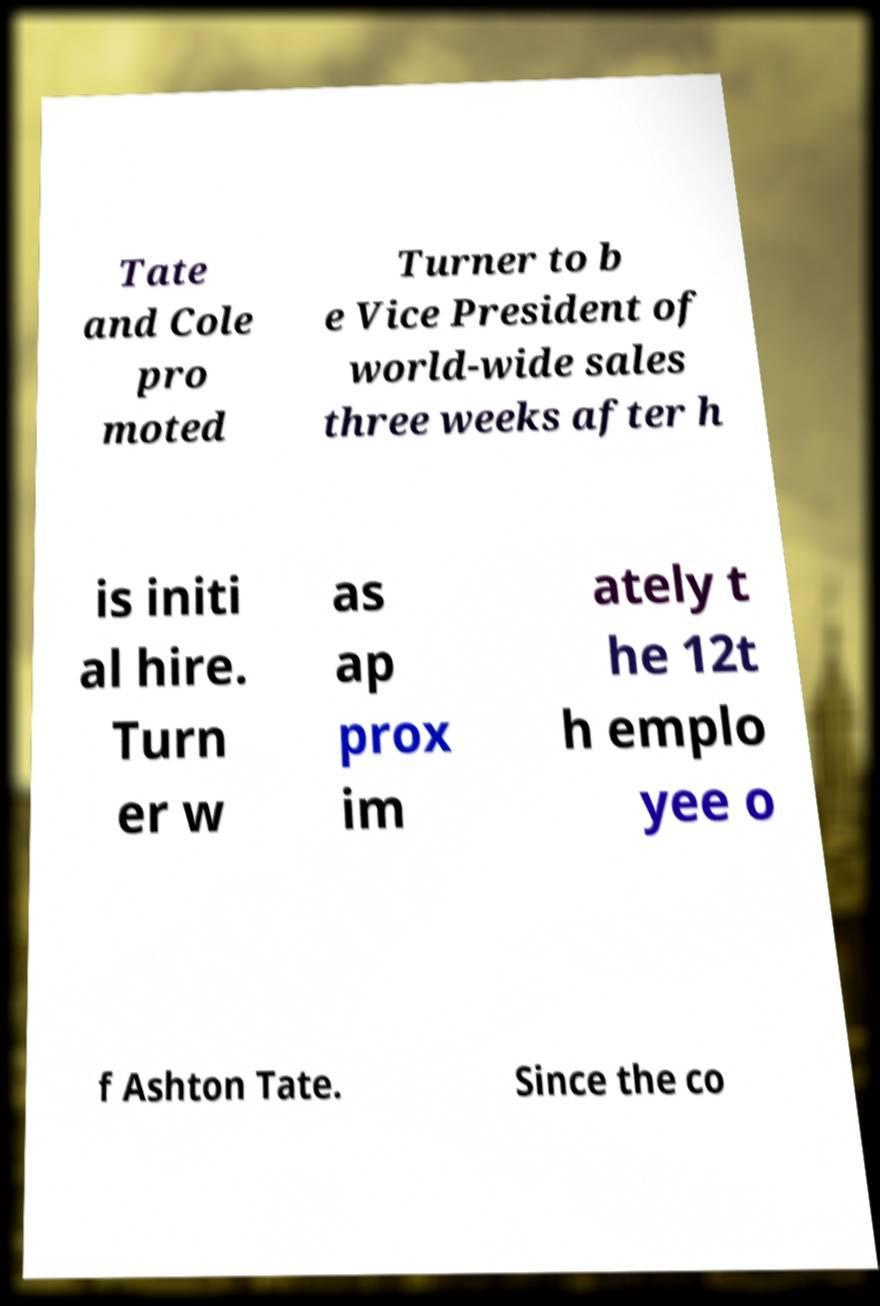Could you assist in decoding the text presented in this image and type it out clearly? Tate and Cole pro moted Turner to b e Vice President of world-wide sales three weeks after h is initi al hire. Turn er w as ap prox im ately t he 12t h emplo yee o f Ashton Tate. Since the co 